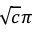<formula> <loc_0><loc_0><loc_500><loc_500>\sqrt { c } \pi</formula> 